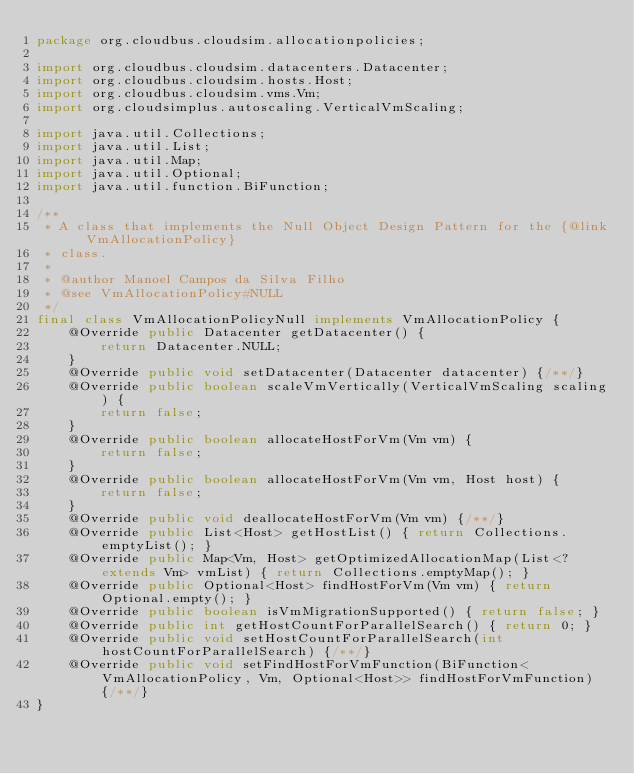Convert code to text. <code><loc_0><loc_0><loc_500><loc_500><_Java_>package org.cloudbus.cloudsim.allocationpolicies;

import org.cloudbus.cloudsim.datacenters.Datacenter;
import org.cloudbus.cloudsim.hosts.Host;
import org.cloudbus.cloudsim.vms.Vm;
import org.cloudsimplus.autoscaling.VerticalVmScaling;

import java.util.Collections;
import java.util.List;
import java.util.Map;
import java.util.Optional;
import java.util.function.BiFunction;

/**
 * A class that implements the Null Object Design Pattern for the {@link VmAllocationPolicy}
 * class.
 *
 * @author Manoel Campos da Silva Filho
 * @see VmAllocationPolicy#NULL
 */
final class VmAllocationPolicyNull implements VmAllocationPolicy {
    @Override public Datacenter getDatacenter() {
        return Datacenter.NULL;
    }
    @Override public void setDatacenter(Datacenter datacenter) {/**/}
    @Override public boolean scaleVmVertically(VerticalVmScaling scaling) {
        return false;
    }
    @Override public boolean allocateHostForVm(Vm vm) {
        return false;
    }
    @Override public boolean allocateHostForVm(Vm vm, Host host) {
        return false;
    }
    @Override public void deallocateHostForVm(Vm vm) {/**/}
    @Override public List<Host> getHostList() { return Collections.emptyList(); }
    @Override public Map<Vm, Host> getOptimizedAllocationMap(List<? extends Vm> vmList) { return Collections.emptyMap(); }
    @Override public Optional<Host> findHostForVm(Vm vm) { return Optional.empty(); }
    @Override public boolean isVmMigrationSupported() { return false; }
    @Override public int getHostCountForParallelSearch() { return 0; }
    @Override public void setHostCountForParallelSearch(int hostCountForParallelSearch) {/**/}
    @Override public void setFindHostForVmFunction(BiFunction<VmAllocationPolicy, Vm, Optional<Host>> findHostForVmFunction) {/**/}
}
</code> 